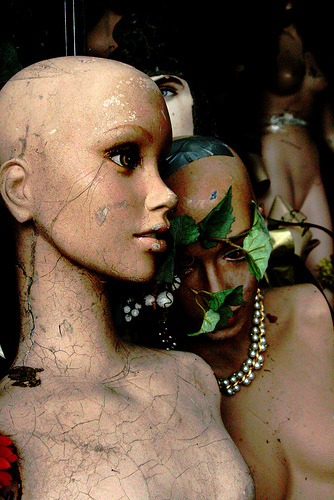<image>
Can you confirm if the doll is under the necklace? No. The doll is not positioned under the necklace. The vertical relationship between these objects is different. 